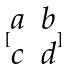Convert formula to latex. <formula><loc_0><loc_0><loc_500><loc_500>[ \begin{matrix} a & b \\ c & d \\ \end{matrix} ]</formula> 